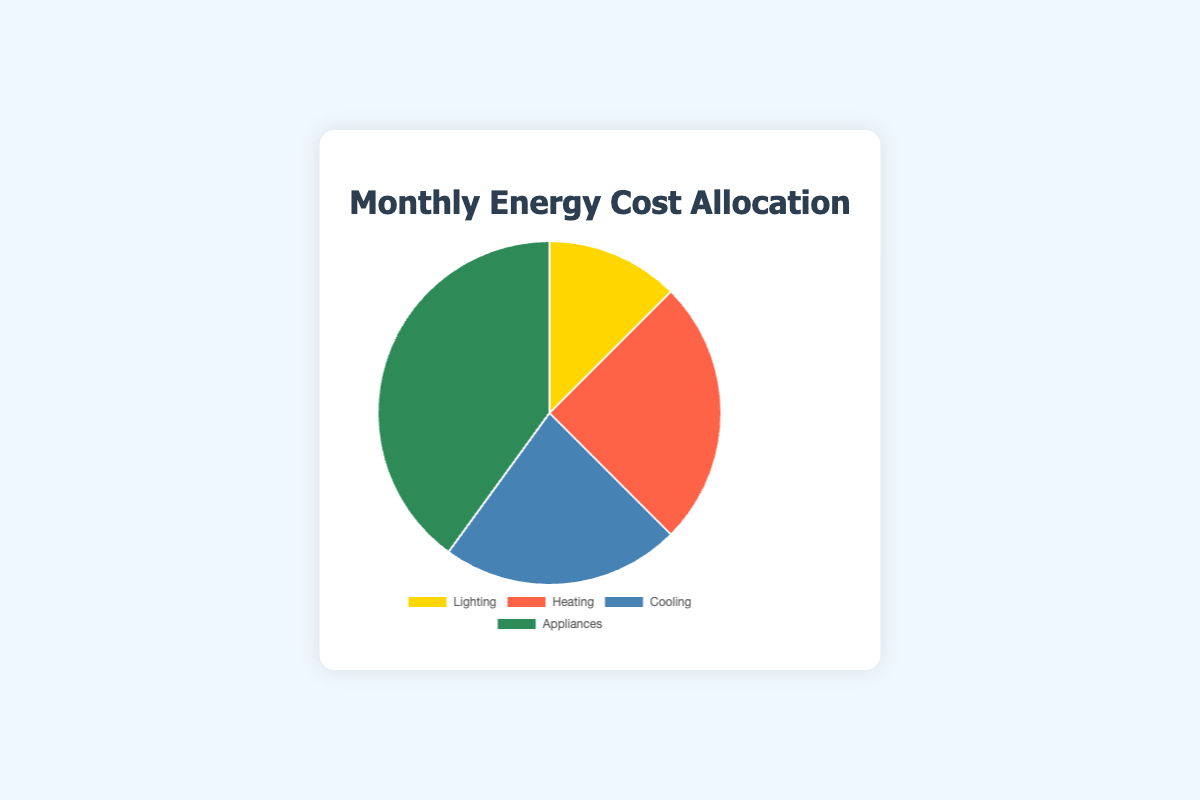What is the monthly cost for Lighting? The chart indicates that the monthly cost allocated to Lighting is represented by a particular segment. According to the data, this segment is labeled as $25.
Answer: $25 Which category has the highest monthly cost allocation? By examining the pie chart, you can see that the largest segment is for Appliances, which corresponds to a monthly cost of $80.
Answer: Appliances How much more is spent on Appliances compared to Cooling each month? The monthly cost for Appliances is $80, and for Cooling, it is $45. The difference is calculated as $80 - $45 = $35.
Answer: $35 Which categories have monthly costs greater than $30? By looking at the pie chart, we note the values: Lighting ($25), Heating ($50), Cooling ($45), and Appliances ($80). The categories with costs greater than $30 are Heating, Cooling, and Appliances.
Answer: Heating, Cooling, Appliances What color represents the segment for Heating? By observing the pie chart, the segment for Heating is represented with a specific color, which is Tomato.
Answer: Tomato What is the total monthly energy cost? By summing the individual costs given: Lighting ($25), Heating ($50), Cooling ($45), and Appliances ($80), the total is $25 + $50 + $45 + $80 = $200.
Answer: $200 How does the monthly cost for Cooling compare to Lighting? From the data, Cooling costs $45 per month, and Lighting costs $25. Since $45 is greater than $25, Cooling has a higher monthly cost.
Answer: Cooling is higher What is the average monthly cost for all categories combined? The combined monthly cost for all categories is $200, and there are 4 categories. The average cost is $200 / 4 = $50.
Answer: $50 Which category contributes to exactly one-quarter of the total monthly energy cost? The total monthly cost is $200, and one-quarter of $200 is $50. Heating has a monthly cost of $50, which is exactly one-quarter of the total.
Answer: Heating 